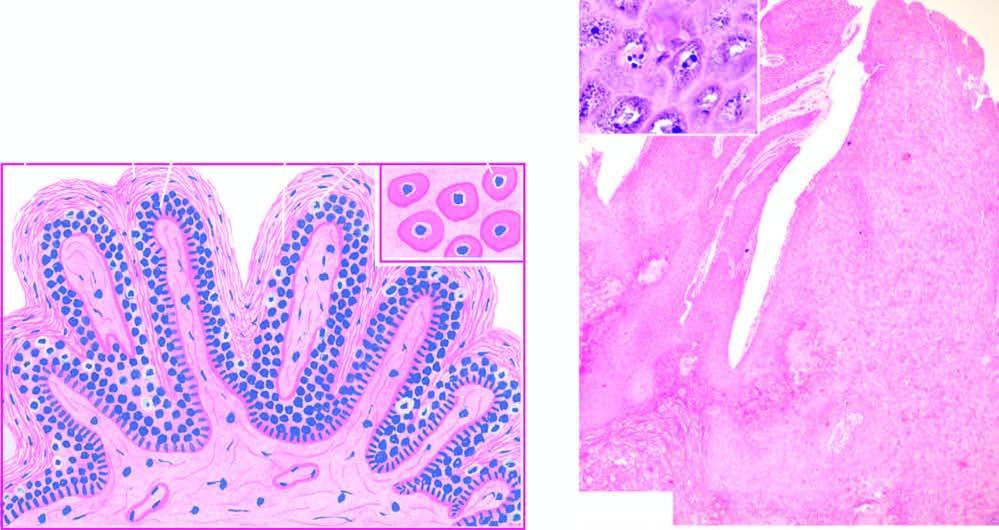what shows koilocytes and virus-infected keratinocytes containing prominent keratohyaline granules?
Answer the question using a single word or phrase. Inset 